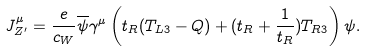Convert formula to latex. <formula><loc_0><loc_0><loc_500><loc_500>J _ { Z ^ { \prime } } ^ { \mu } = \frac { e } { c _ { W } } \overline { \psi } \gamma ^ { \mu } \left ( t _ { R } ( T _ { L 3 } - Q ) + ( t _ { R } + \frac { 1 } { t _ { R } } ) T _ { R 3 } \right ) \psi .</formula> 